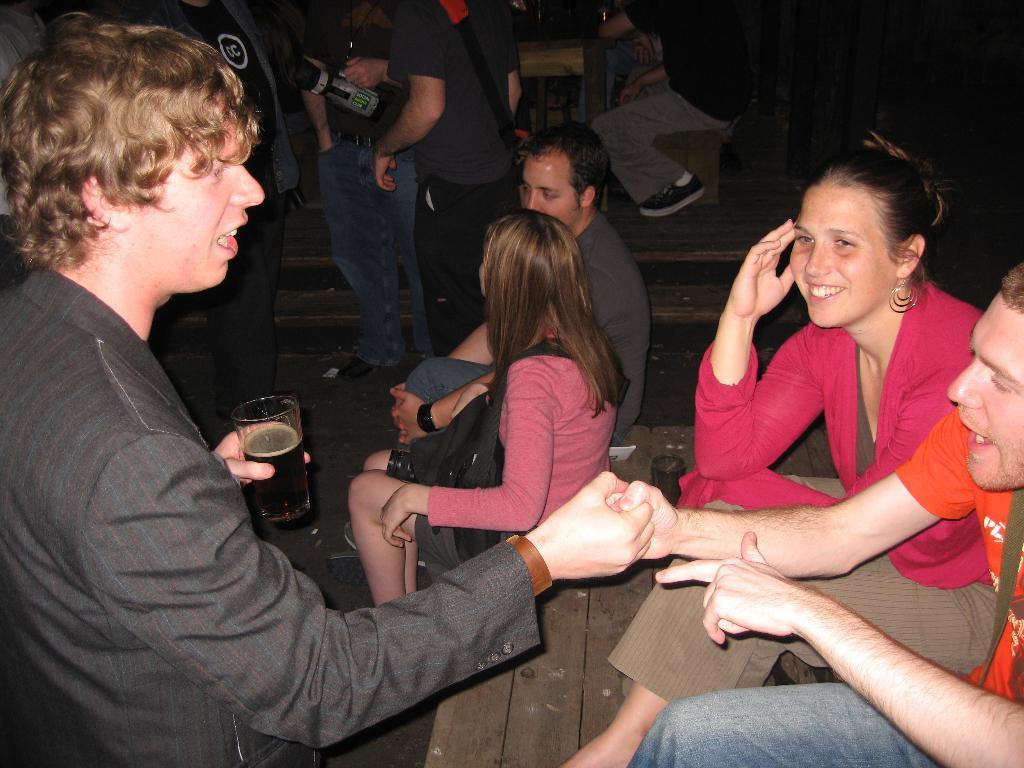Can you describe this image briefly? On the right of this picture we can see the group of persons sitting and a person holding a glass of drink and standing. In the background we can see the group of persons, wooden tables and some other objects. 